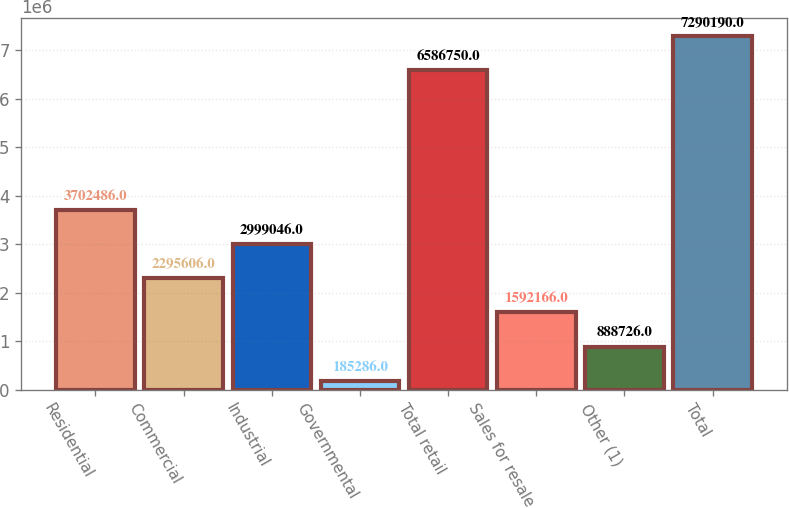<chart> <loc_0><loc_0><loc_500><loc_500><bar_chart><fcel>Residential<fcel>Commercial<fcel>Industrial<fcel>Governmental<fcel>Total retail<fcel>Sales for resale<fcel>Other (1)<fcel>Total<nl><fcel>3.70249e+06<fcel>2.29561e+06<fcel>2.99905e+06<fcel>185286<fcel>6.58675e+06<fcel>1.59217e+06<fcel>888726<fcel>7.29019e+06<nl></chart> 